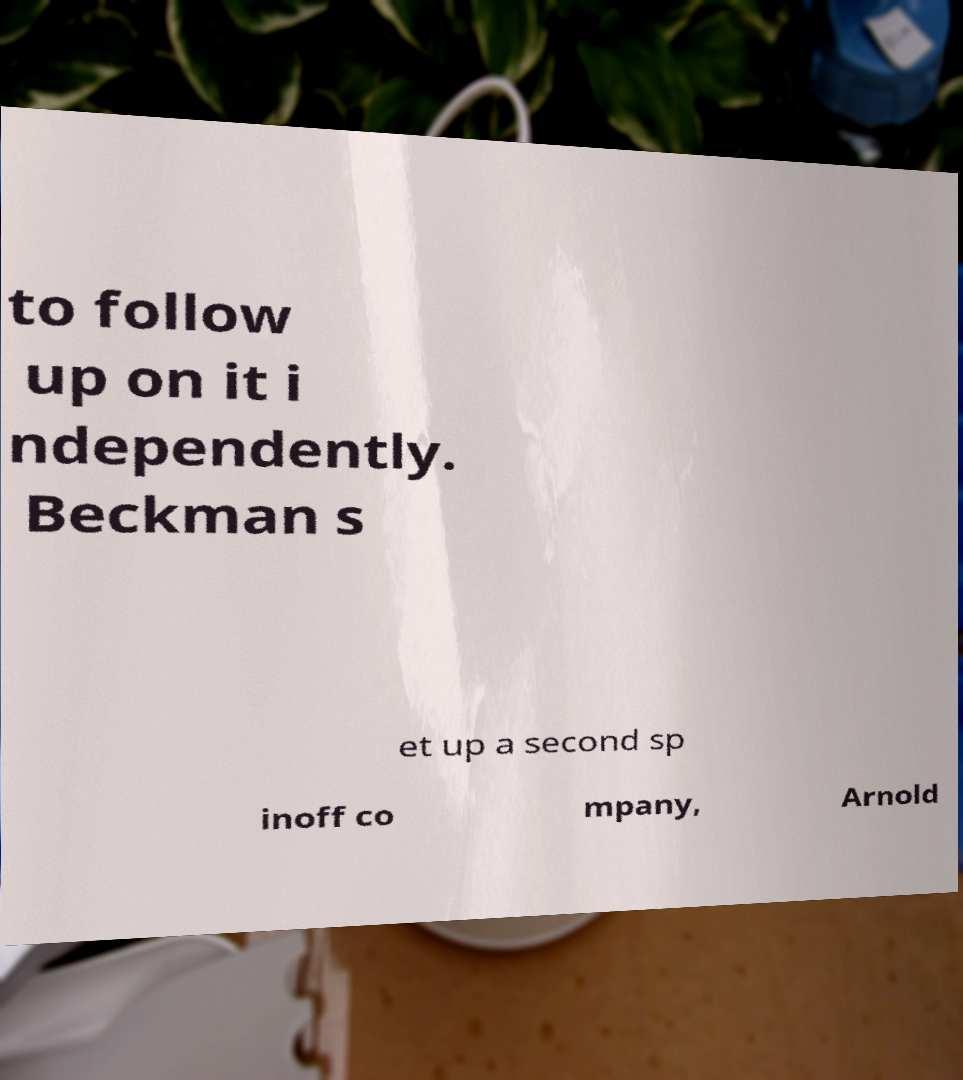What messages or text are displayed in this image? I need them in a readable, typed format. to follow up on it i ndependently. Beckman s et up a second sp inoff co mpany, Arnold 